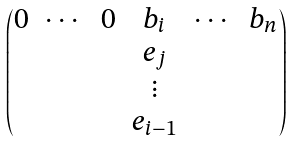<formula> <loc_0><loc_0><loc_500><loc_500>\begin{pmatrix} 0 & \cdots & 0 & b _ { i } & \cdots & b _ { n } \\ & & & e _ { j } \\ & & & \vdots \\ & & & e _ { i - 1 } \end{pmatrix}</formula> 